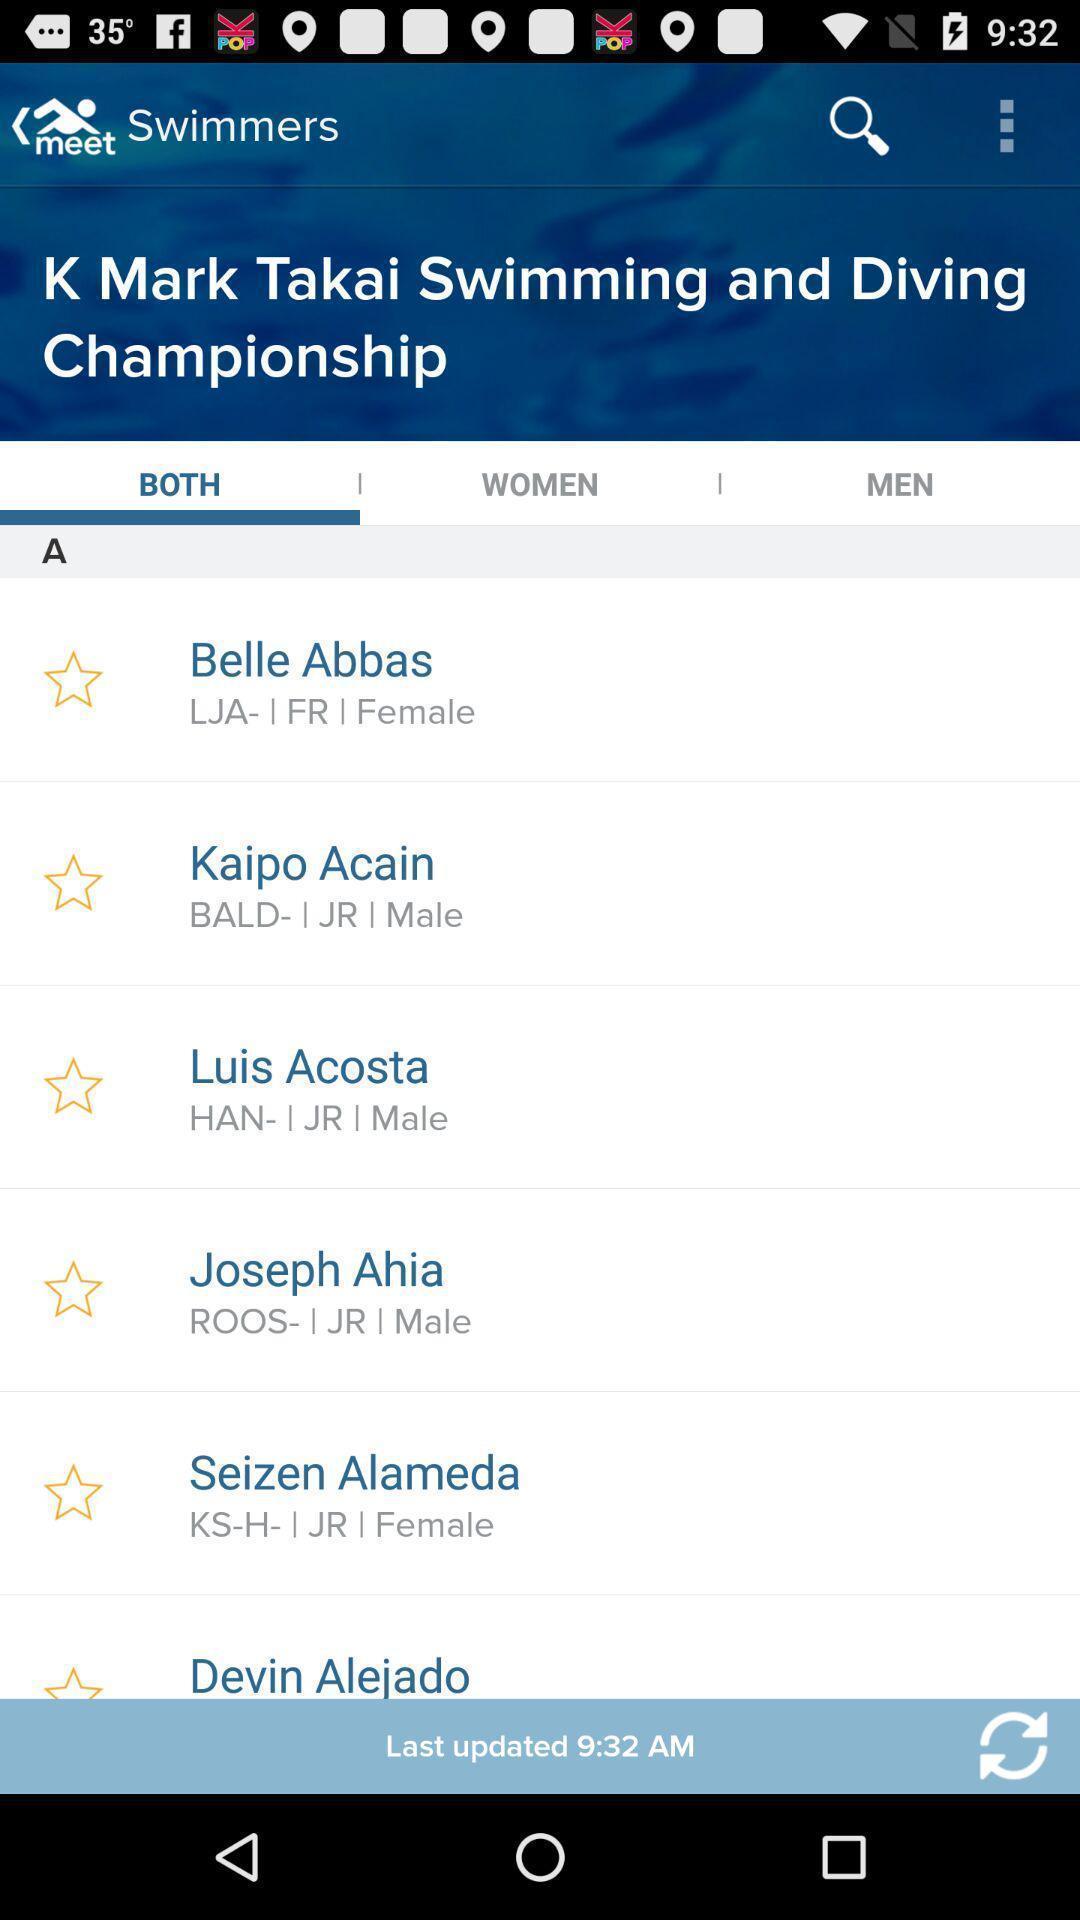Summarize the information in this screenshot. Page with list of people details of swimmers. 